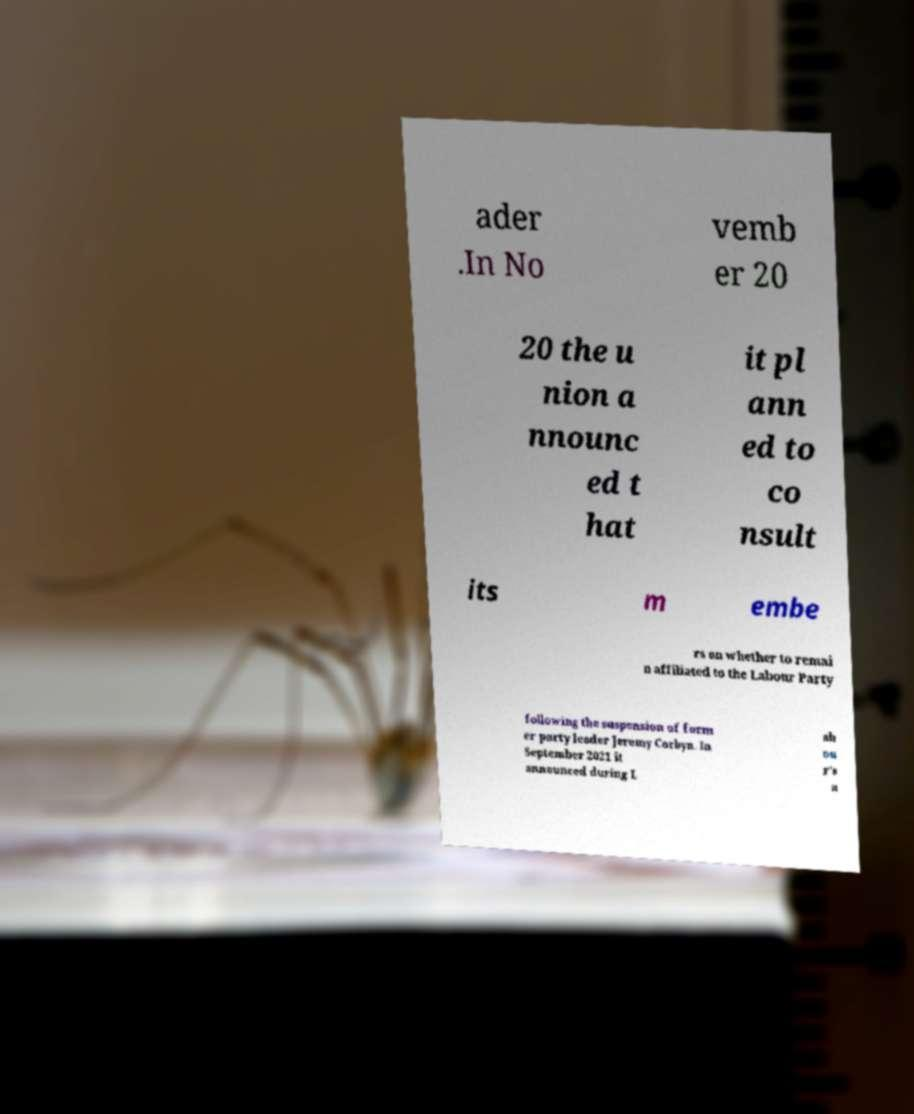I need the written content from this picture converted into text. Can you do that? ader .In No vemb er 20 20 the u nion a nnounc ed t hat it pl ann ed to co nsult its m embe rs on whether to remai n affiliated to the Labour Party following the suspension of form er party leader Jeremy Corbyn. In September 2021 it announced during L ab ou r's a 